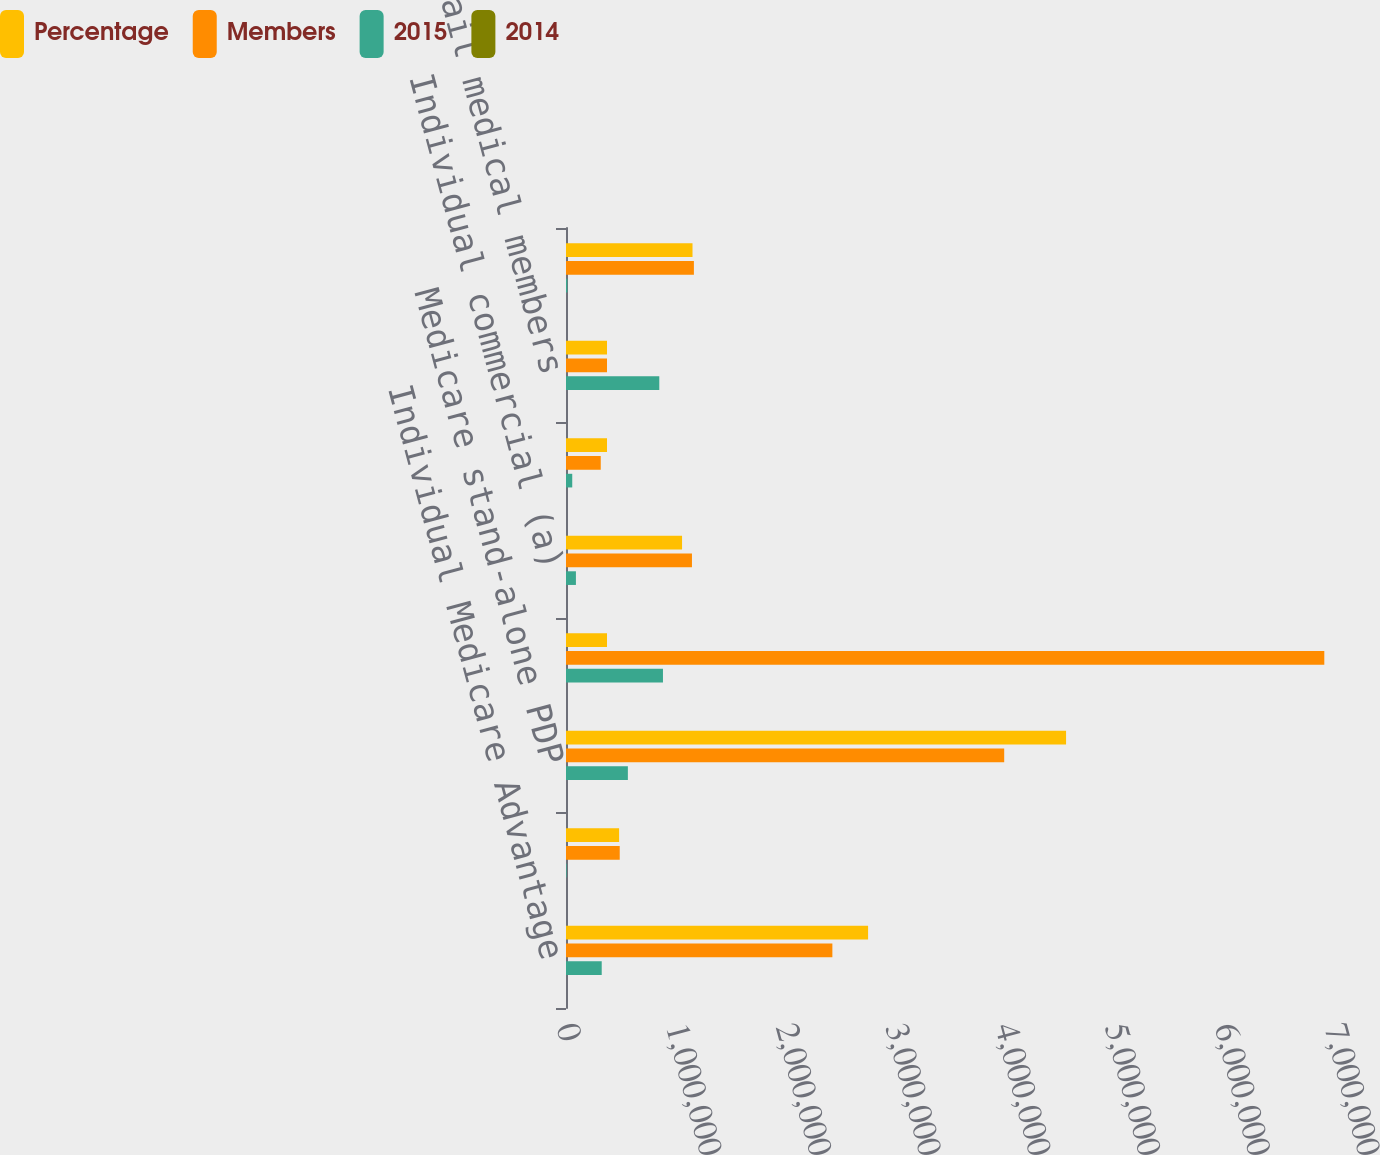Convert chart to OTSL. <chart><loc_0><loc_0><loc_500><loc_500><stacked_bar_chart><ecel><fcel>Individual Medicare Advantage<fcel>Group Medicare Advantage<fcel>Medicare stand-alone PDP<fcel>Total Retail Medicare<fcel>Individual commercial (a)<fcel>State-based Medicaid<fcel>Total Retail medical members<fcel>Individual specialty<nl><fcel>Percentage<fcel>2.7534e+06<fcel>484100<fcel>4.5579e+06<fcel>373700<fcel>1.0577e+06<fcel>373700<fcel>373700<fcel>1.1531e+06<nl><fcel>Members<fcel>2.4279e+06<fcel>489700<fcel>3.994e+06<fcel>6.9116e+06<fcel>1.1481e+06<fcel>316800<fcel>373700<fcel>1.1658e+06<nl><fcel>2015<fcel>325500<fcel>5600<fcel>563900<fcel>883800<fcel>90400<fcel>56900<fcel>850300<fcel>12700<nl><fcel>2014<fcel>13.4<fcel>1.1<fcel>14.1<fcel>12.8<fcel>7.9<fcel>18<fcel>10.2<fcel>1.1<nl></chart> 